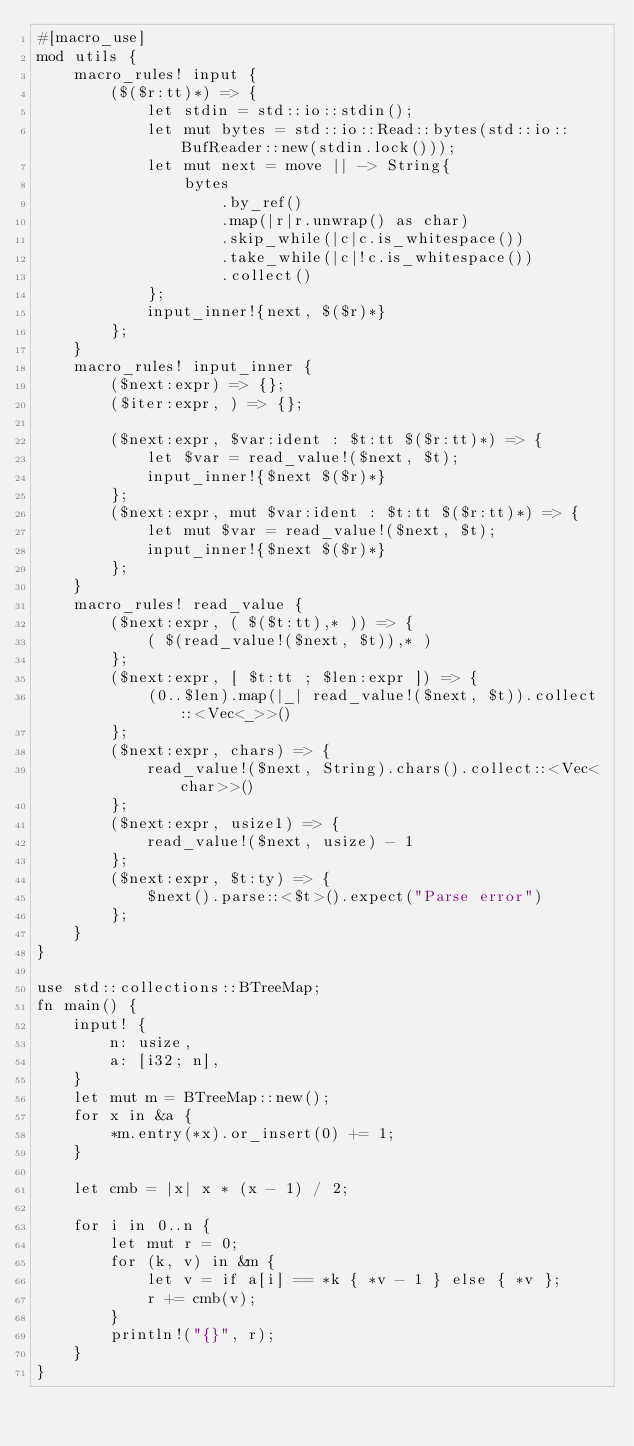Convert code to text. <code><loc_0><loc_0><loc_500><loc_500><_Rust_>#[macro_use]
mod utils {
    macro_rules! input {
        ($($r:tt)*) => {
            let stdin = std::io::stdin();
            let mut bytes = std::io::Read::bytes(std::io::BufReader::new(stdin.lock()));
            let mut next = move || -> String{
                bytes
                    .by_ref()
                    .map(|r|r.unwrap() as char)
                    .skip_while(|c|c.is_whitespace())
                    .take_while(|c|!c.is_whitespace())
                    .collect()
            };
            input_inner!{next, $($r)*}
        };
    }
    macro_rules! input_inner {
        ($next:expr) => {};
        ($iter:expr, ) => {};

        ($next:expr, $var:ident : $t:tt $($r:tt)*) => {
            let $var = read_value!($next, $t);
            input_inner!{$next $($r)*}
        };
        ($next:expr, mut $var:ident : $t:tt $($r:tt)*) => {
            let mut $var = read_value!($next, $t);
            input_inner!{$next $($r)*}
        };
    }
    macro_rules! read_value {
        ($next:expr, ( $($t:tt),* )) => {
            ( $(read_value!($next, $t)),* )
        };
        ($next:expr, [ $t:tt ; $len:expr ]) => {
            (0..$len).map(|_| read_value!($next, $t)).collect::<Vec<_>>()
        };
        ($next:expr, chars) => {
            read_value!($next, String).chars().collect::<Vec<char>>()
        };
        ($next:expr, usize1) => {
            read_value!($next, usize) - 1
        };
        ($next:expr, $t:ty) => {
            $next().parse::<$t>().expect("Parse error")
        };
    }
}

use std::collections::BTreeMap;
fn main() {
    input! {
        n: usize,
        a: [i32; n],
    }
    let mut m = BTreeMap::new();
    for x in &a {
        *m.entry(*x).or_insert(0) += 1;
    }

    let cmb = |x| x * (x - 1) / 2;

    for i in 0..n {
        let mut r = 0;
        for (k, v) in &m {
            let v = if a[i] == *k { *v - 1 } else { *v };
            r += cmb(v);
        }
        println!("{}", r);
    }
}
</code> 